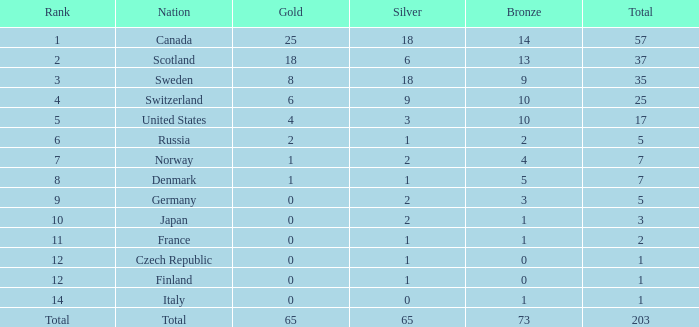What is the total number of medals when there are 18 gold medals? 37.0. 